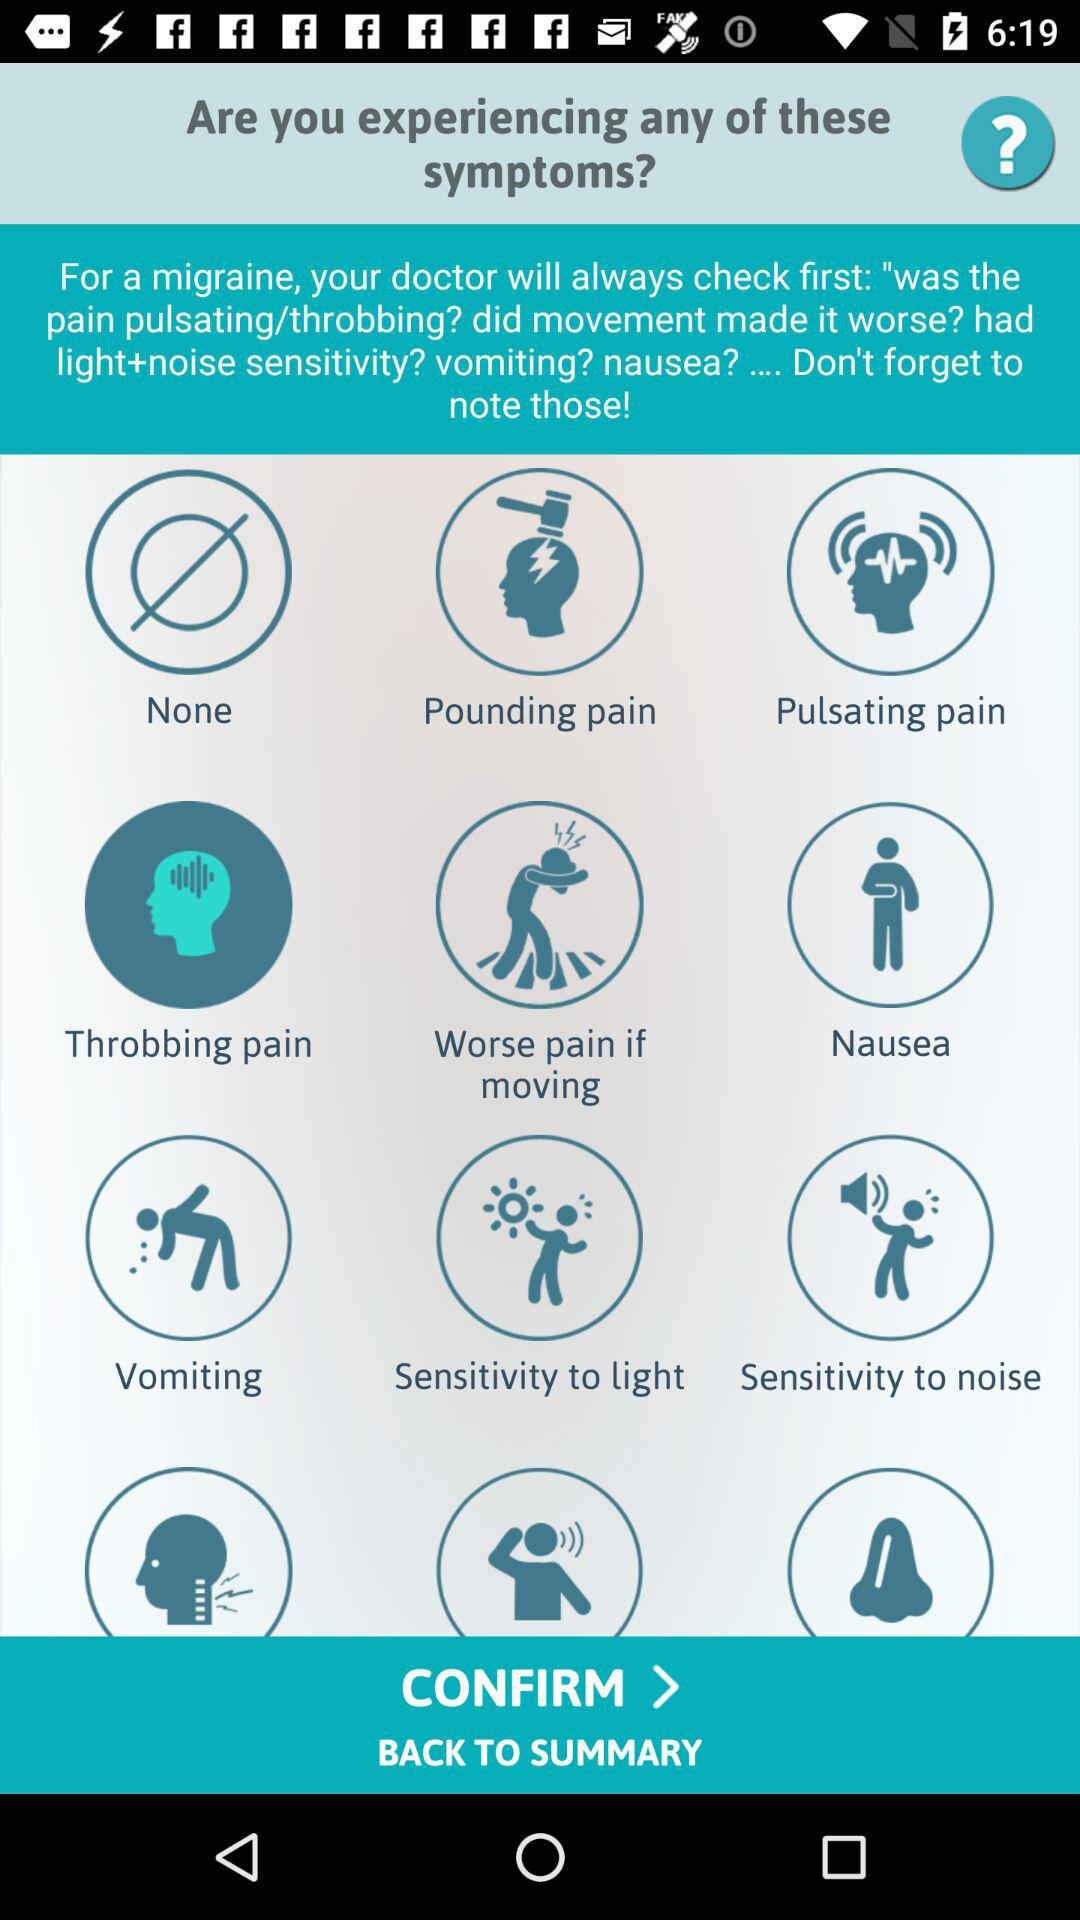What is the selected symptom? The selected symptom is "Throbbing pain". 